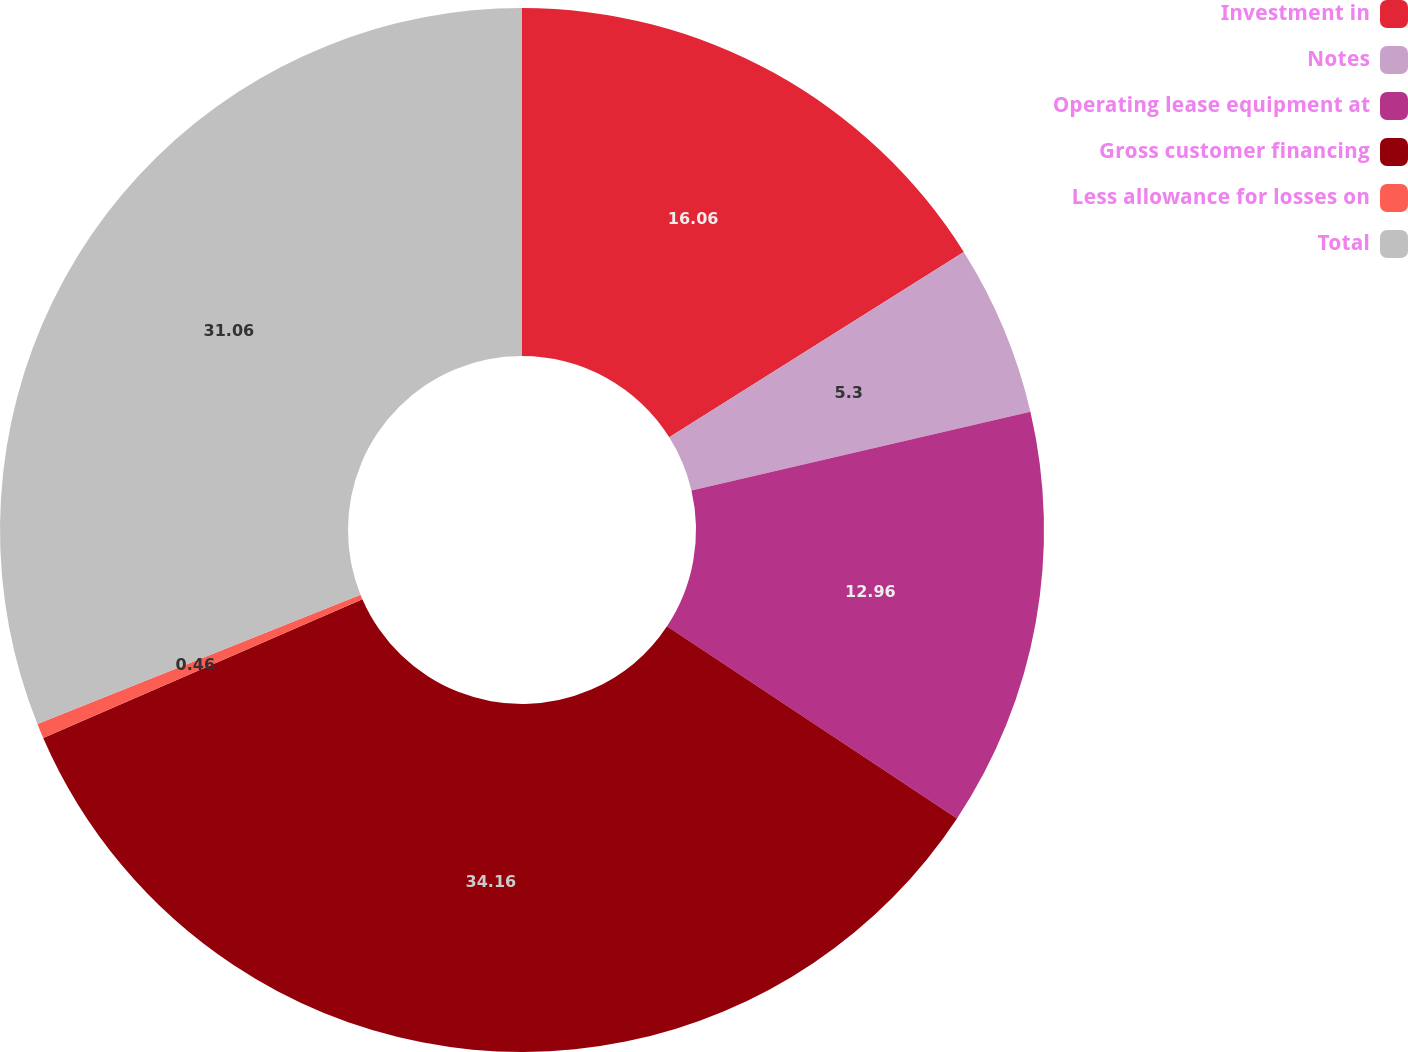Convert chart to OTSL. <chart><loc_0><loc_0><loc_500><loc_500><pie_chart><fcel>Investment in<fcel>Notes<fcel>Operating lease equipment at<fcel>Gross customer financing<fcel>Less allowance for losses on<fcel>Total<nl><fcel>16.06%<fcel>5.3%<fcel>12.96%<fcel>34.16%<fcel>0.46%<fcel>31.06%<nl></chart> 